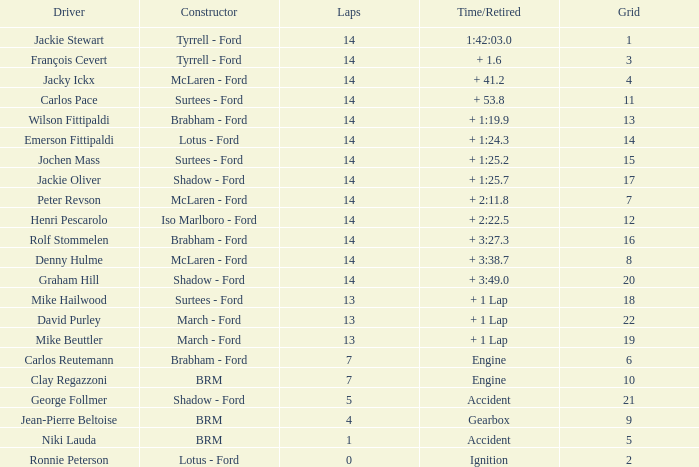3? 14.0. 